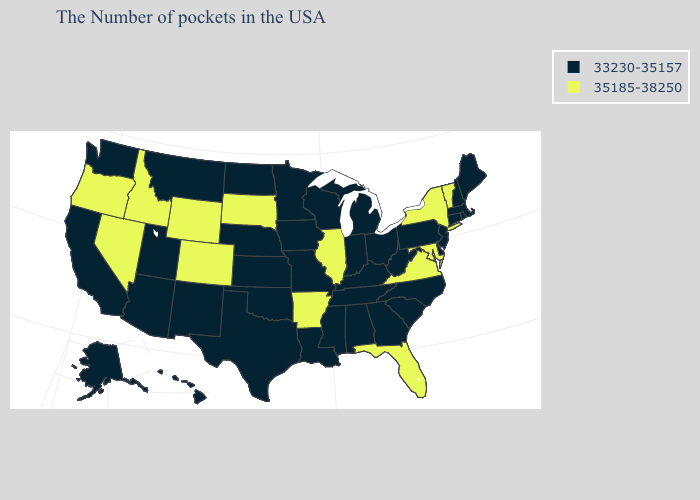Name the states that have a value in the range 33230-35157?
Short answer required. Maine, Massachusetts, Rhode Island, New Hampshire, Connecticut, New Jersey, Delaware, Pennsylvania, North Carolina, South Carolina, West Virginia, Ohio, Georgia, Michigan, Kentucky, Indiana, Alabama, Tennessee, Wisconsin, Mississippi, Louisiana, Missouri, Minnesota, Iowa, Kansas, Nebraska, Oklahoma, Texas, North Dakota, New Mexico, Utah, Montana, Arizona, California, Washington, Alaska, Hawaii. Name the states that have a value in the range 35185-38250?
Be succinct. Vermont, New York, Maryland, Virginia, Florida, Illinois, Arkansas, South Dakota, Wyoming, Colorado, Idaho, Nevada, Oregon. Name the states that have a value in the range 33230-35157?
Write a very short answer. Maine, Massachusetts, Rhode Island, New Hampshire, Connecticut, New Jersey, Delaware, Pennsylvania, North Carolina, South Carolina, West Virginia, Ohio, Georgia, Michigan, Kentucky, Indiana, Alabama, Tennessee, Wisconsin, Mississippi, Louisiana, Missouri, Minnesota, Iowa, Kansas, Nebraska, Oklahoma, Texas, North Dakota, New Mexico, Utah, Montana, Arizona, California, Washington, Alaska, Hawaii. How many symbols are there in the legend?
Answer briefly. 2. Which states have the lowest value in the MidWest?
Concise answer only. Ohio, Michigan, Indiana, Wisconsin, Missouri, Minnesota, Iowa, Kansas, Nebraska, North Dakota. Name the states that have a value in the range 35185-38250?
Short answer required. Vermont, New York, Maryland, Virginia, Florida, Illinois, Arkansas, South Dakota, Wyoming, Colorado, Idaho, Nevada, Oregon. Among the states that border Mississippi , which have the lowest value?
Concise answer only. Alabama, Tennessee, Louisiana. Name the states that have a value in the range 33230-35157?
Be succinct. Maine, Massachusetts, Rhode Island, New Hampshire, Connecticut, New Jersey, Delaware, Pennsylvania, North Carolina, South Carolina, West Virginia, Ohio, Georgia, Michigan, Kentucky, Indiana, Alabama, Tennessee, Wisconsin, Mississippi, Louisiana, Missouri, Minnesota, Iowa, Kansas, Nebraska, Oklahoma, Texas, North Dakota, New Mexico, Utah, Montana, Arizona, California, Washington, Alaska, Hawaii. Does the first symbol in the legend represent the smallest category?
Concise answer only. Yes. Which states have the highest value in the USA?
Be succinct. Vermont, New York, Maryland, Virginia, Florida, Illinois, Arkansas, South Dakota, Wyoming, Colorado, Idaho, Nevada, Oregon. What is the highest value in the MidWest ?
Answer briefly. 35185-38250. How many symbols are there in the legend?
Write a very short answer. 2. Among the states that border Vermont , does Massachusetts have the lowest value?
Quick response, please. Yes. What is the value of Washington?
Be succinct. 33230-35157. Which states have the lowest value in the USA?
Be succinct. Maine, Massachusetts, Rhode Island, New Hampshire, Connecticut, New Jersey, Delaware, Pennsylvania, North Carolina, South Carolina, West Virginia, Ohio, Georgia, Michigan, Kentucky, Indiana, Alabama, Tennessee, Wisconsin, Mississippi, Louisiana, Missouri, Minnesota, Iowa, Kansas, Nebraska, Oklahoma, Texas, North Dakota, New Mexico, Utah, Montana, Arizona, California, Washington, Alaska, Hawaii. 